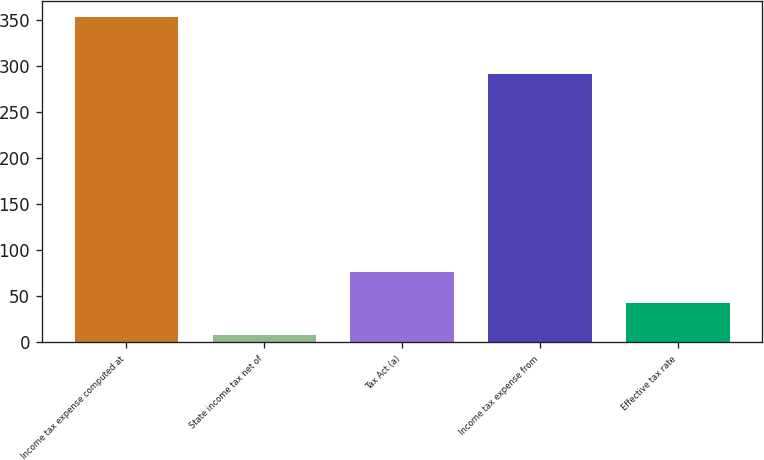<chart> <loc_0><loc_0><loc_500><loc_500><bar_chart><fcel>Income tax expense computed at<fcel>State income tax net of<fcel>Tax Act (a)<fcel>Income tax expense from<fcel>Effective tax rate<nl><fcel>353<fcel>8<fcel>77<fcel>292<fcel>42.5<nl></chart> 